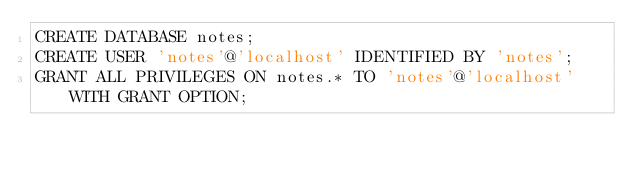<code> <loc_0><loc_0><loc_500><loc_500><_SQL_>CREATE DATABASE notes;
CREATE USER 'notes'@'localhost' IDENTIFIED BY 'notes';
GRANT ALL PRIVILEGES ON notes.* TO 'notes'@'localhost' WITH GRANT OPTION;</code> 